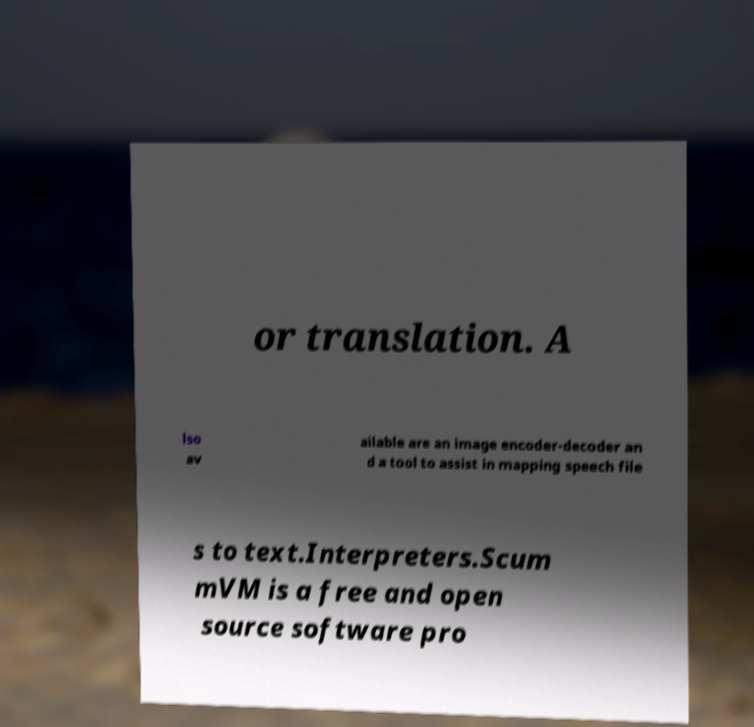What messages or text are displayed in this image? I need them in a readable, typed format. or translation. A lso av ailable are an image encoder-decoder an d a tool to assist in mapping speech file s to text.Interpreters.Scum mVM is a free and open source software pro 